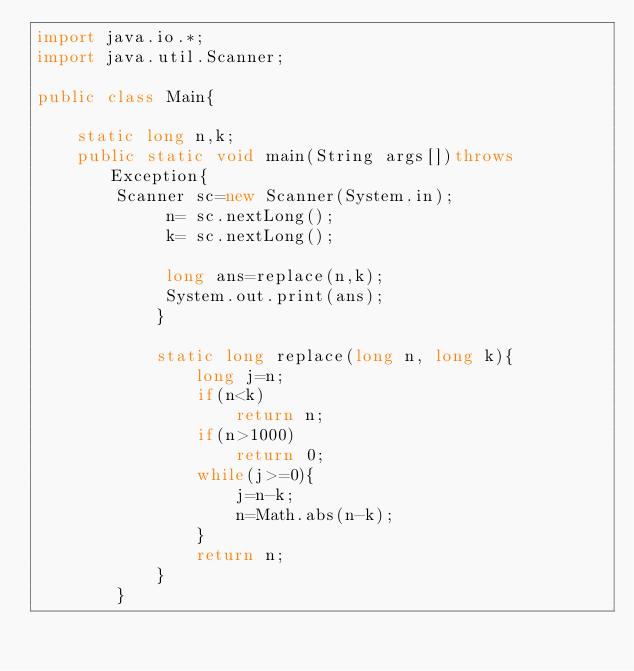Convert code to text. <code><loc_0><loc_0><loc_500><loc_500><_Java_>import java.io.*;
import java.util.Scanner;

public class Main{

	static long n,k;
	public static void main(String args[])throws Exception{
		Scanner sc=new Scanner(System.in);
			 n= sc.nextLong();
			 k= sc.nextLong();

			 long ans=replace(n,k);
			 System.out.print(ans);
			}

			static long replace(long n, long k){
				long j=n;
				if(n<k)
					return n;
				if(n>1000)
					return 0;
				while(j>=0){
					j=n-k;
					n=Math.abs(n-k);
				}
				return n;
			}
		}

</code> 